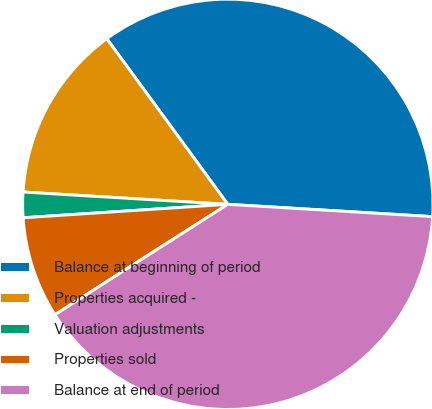Convert chart. <chart><loc_0><loc_0><loc_500><loc_500><pie_chart><fcel>Balance at beginning of period<fcel>Properties acquired -<fcel>Valuation adjustments<fcel>Properties sold<fcel>Balance at end of period<nl><fcel>36.0%<fcel>14.0%<fcel>2.0%<fcel>8.0%<fcel>40.0%<nl></chart> 